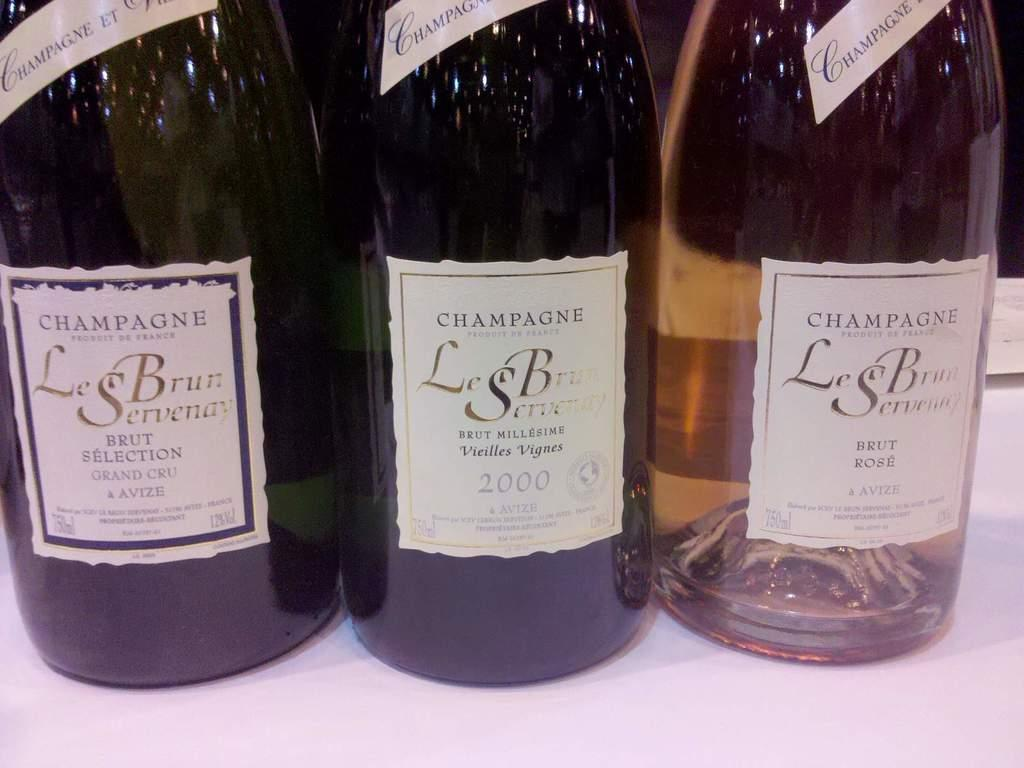Provide a one-sentence caption for the provided image. Three LeBrun Servenay wine bottles are on a white table cloth. 